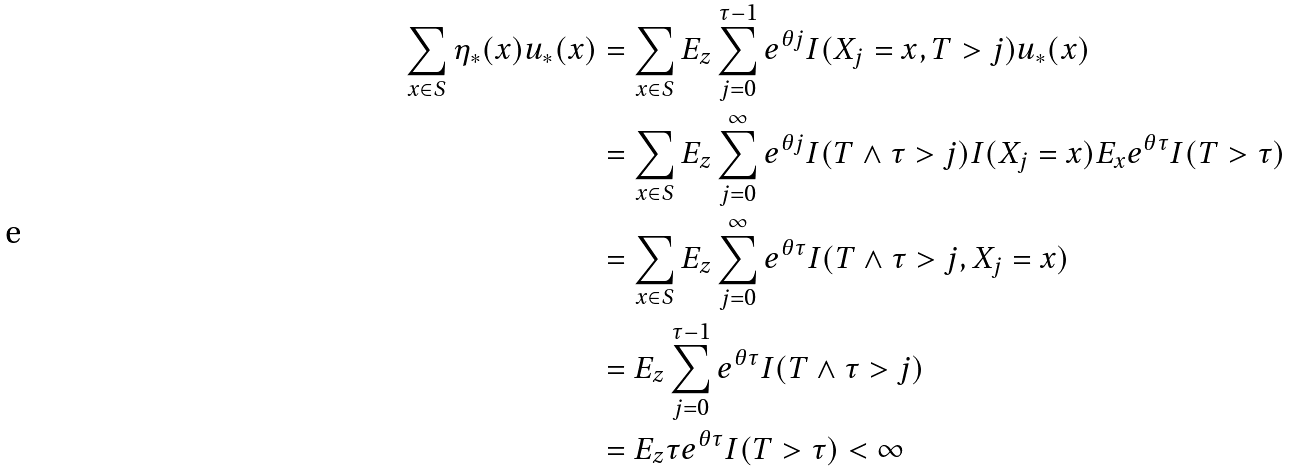<formula> <loc_0><loc_0><loc_500><loc_500>\sum _ { x \in S } \eta _ { * } ( x ) u _ { * } ( x ) & = \sum _ { x \in S } E _ { z } \sum _ { j = 0 } ^ { \tau - 1 } e ^ { \theta j } I ( X _ { j } = x , T > j ) u _ { * } ( x ) \\ & = \sum _ { x \in S } E _ { z } \sum _ { j = 0 } ^ { \infty } e ^ { \theta j } I ( T \wedge \tau > j ) I ( X _ { j } = x ) E _ { x } e ^ { \theta \tau } I ( T > \tau ) \\ & = \sum _ { x \in S } E _ { z } \sum _ { j = 0 } ^ { \infty } e ^ { \theta \tau } I ( T \wedge \tau > j , X _ { j } = x ) \\ & = E _ { z } \sum _ { j = 0 } ^ { \tau - 1 } e ^ { \theta \tau } I ( T \wedge \tau > j ) \\ & = E _ { z } \tau e ^ { \theta \tau } I ( T > \tau ) < \infty</formula> 